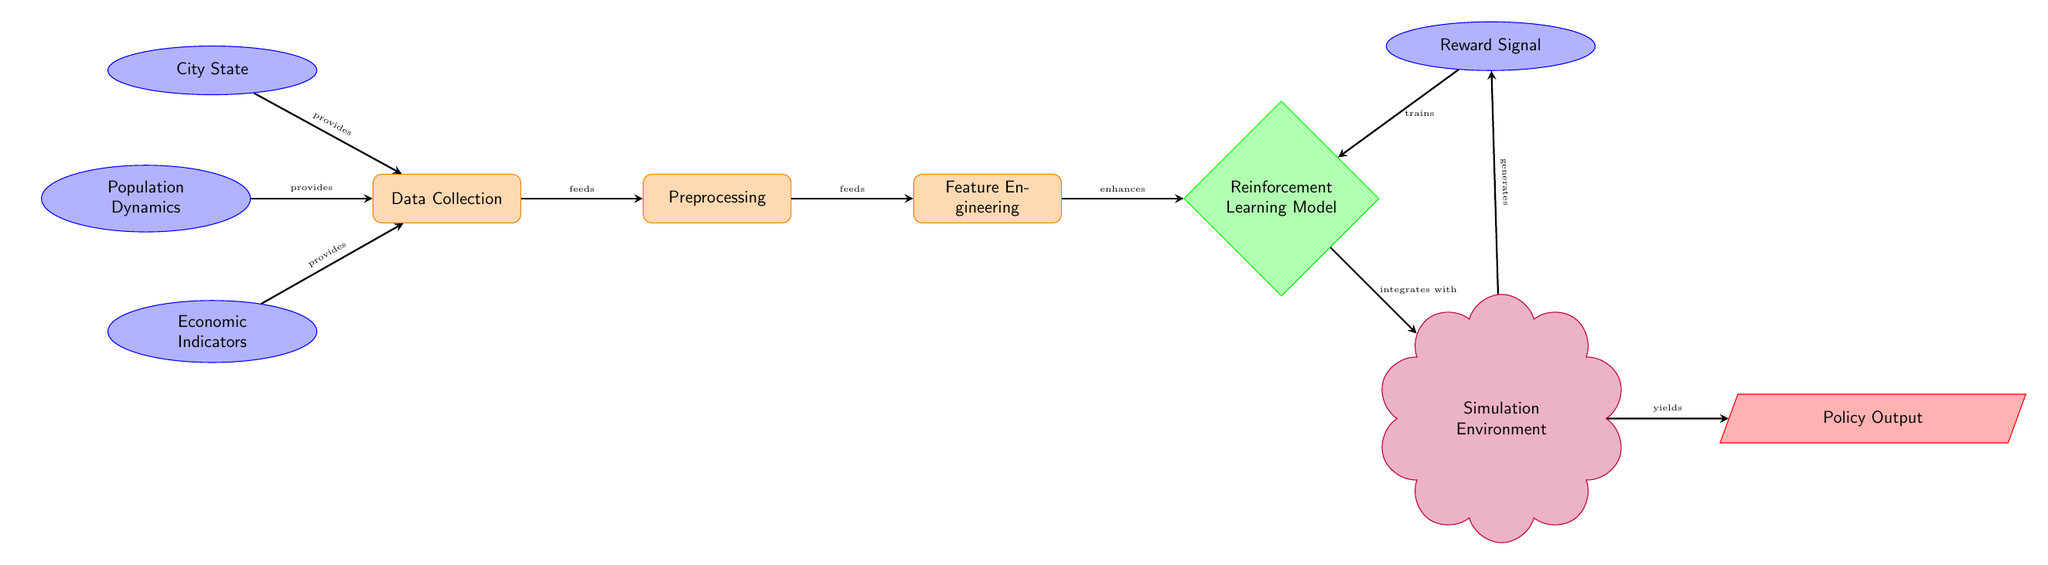What provides data to the data collection process? The diagram shows three data sources: City State, Population Dynamics, and Economic Indicators, all connected to the Data Collection process with arrows indicating that they provide data for it.
Answer: City State, Population Dynamics, Economic Indicators What type of model is used in this diagram? The diagram prominently features a node labeled as Reinforcement Learning Model, which indicates the specific type of model used in the process.
Answer: Reinforcement Learning Model How many edges are there in the diagram? By counting the arrows that connect nodes, there are a total of seven edges represented in the diagram.
Answer: Seven What does the preprocessing node do? The diagram indicates that the Preprocessing node receives input from the Data Collection node and then feeds into the Feature Engineering node, indicating its role in preparing data for further analysis.
Answer: Prepares data What is the role of the simulation environment? The Simulation Environment integrates with the Reinforcement Learning Model and generates policy outputs, evidencing its role in testing the model's interactions within a simulated scenario.
Answer: Test interactions Which node trains the reinforcement learning model? The arrow labeled "trains" indicates that the Reward Signal node is the one responsible for training the Reinforcement Learning Model.
Answer: Reward Signal What data flows from the simulation environment? The diagram shows that the Simulation Environment generates a Policy Output, explicitly highlighting the output it provides after processing data.
Answer: Policy Output What node enhances the reinforcement learning model? The diagram shows a direct link from the Feature Engineering node to the Reinforcement Learning Model, denoting the enhancement relationship between them.
Answer: Feature Engineering What is the simulation environment dependent on? The Simulation Environment relies on integration with the Reinforcement Learning Model, as depicted by the connecting arrow illustrating that it works closely with the model.
Answer: Reinforcement Learning Model 